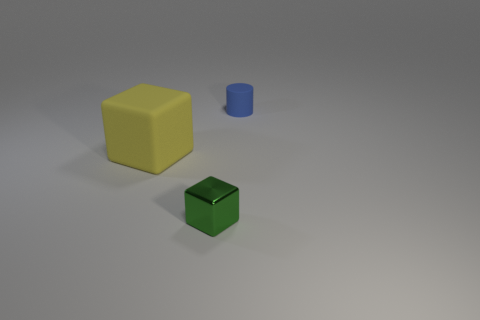Is there any other thing that has the same size as the yellow matte object?
Your answer should be very brief. No. Is there anything else that is the same material as the tiny block?
Offer a terse response. No. How many other things are the same size as the yellow thing?
Make the answer very short. 0. There is a green shiny cube; does it have the same size as the matte object to the right of the matte cube?
Your answer should be compact. Yes. The cylinder that is the same size as the green metallic block is what color?
Ensure brevity in your answer.  Blue. The yellow rubber block is what size?
Make the answer very short. Large. Are the thing that is behind the big yellow object and the big yellow object made of the same material?
Offer a terse response. Yes. Do the big yellow rubber object and the small green metal thing have the same shape?
Provide a short and direct response. Yes. The tiny shiny thing that is right of the matte object that is left of the block that is right of the large yellow object is what shape?
Make the answer very short. Cube. Does the small thing on the right side of the small shiny cube have the same shape as the thing that is in front of the big yellow rubber block?
Make the answer very short. No. 